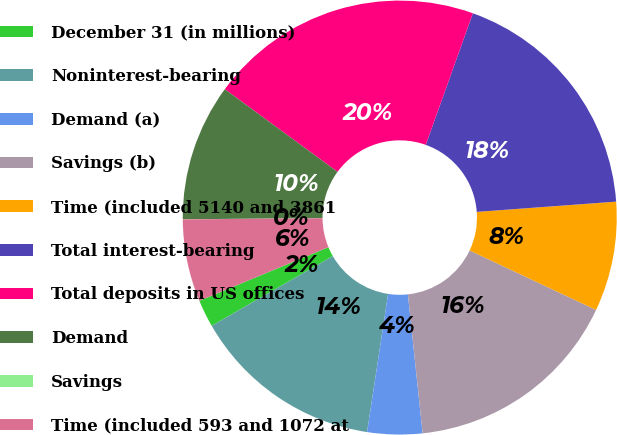Convert chart. <chart><loc_0><loc_0><loc_500><loc_500><pie_chart><fcel>December 31 (in millions)<fcel>Noninterest-bearing<fcel>Demand (a)<fcel>Savings (b)<fcel>Time (included 5140 and 3861<fcel>Total interest-bearing<fcel>Total deposits in US offices<fcel>Demand<fcel>Savings<fcel>Time (included 593 and 1072 at<nl><fcel>2.05%<fcel>14.28%<fcel>4.09%<fcel>16.32%<fcel>8.17%<fcel>18.36%<fcel>20.4%<fcel>10.2%<fcel>0.01%<fcel>6.13%<nl></chart> 